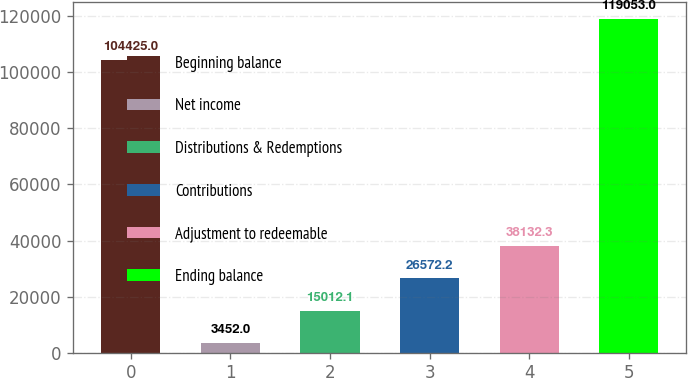Convert chart. <chart><loc_0><loc_0><loc_500><loc_500><bar_chart><fcel>Beginning balance<fcel>Net income<fcel>Distributions & Redemptions<fcel>Contributions<fcel>Adjustment to redeemable<fcel>Ending balance<nl><fcel>104425<fcel>3452<fcel>15012.1<fcel>26572.2<fcel>38132.3<fcel>119053<nl></chart> 